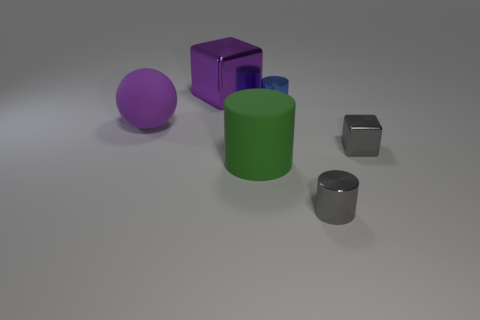Subtract all large cylinders. How many cylinders are left? 2 Add 4 big purple shiny blocks. How many objects exist? 10 Subtract all purple blocks. How many blocks are left? 1 Subtract all spheres. How many objects are left? 5 Subtract 1 blocks. How many blocks are left? 1 Subtract all blue cylinders. Subtract all blue blocks. How many cylinders are left? 2 Subtract all big cylinders. Subtract all large things. How many objects are left? 2 Add 6 small metal cubes. How many small metal cubes are left? 7 Add 6 gray cubes. How many gray cubes exist? 7 Subtract 0 brown spheres. How many objects are left? 6 